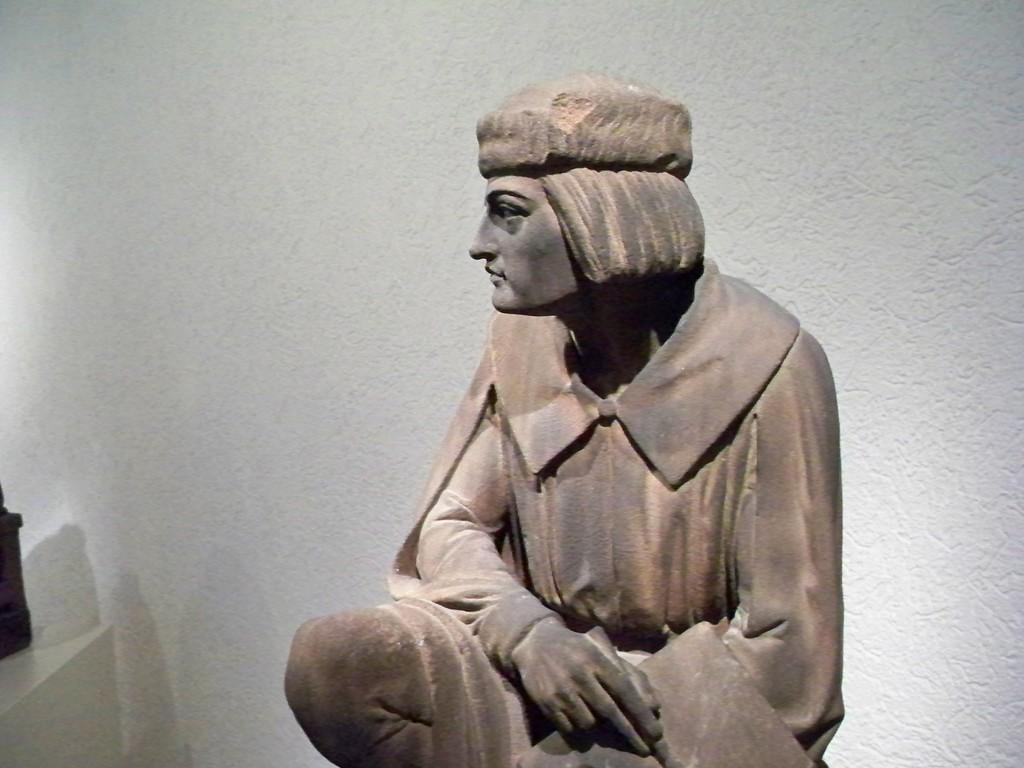What is the main subject in the foreground of the picture? There is a sculpture in the foreground of the picture. What can be seen behind the sculpture? The wall behind the sculpture is painted white. What type of steam is coming out of the sculpture in the image? There is no steam coming out of the sculpture in the image; it is a sculpture made of solid material. 